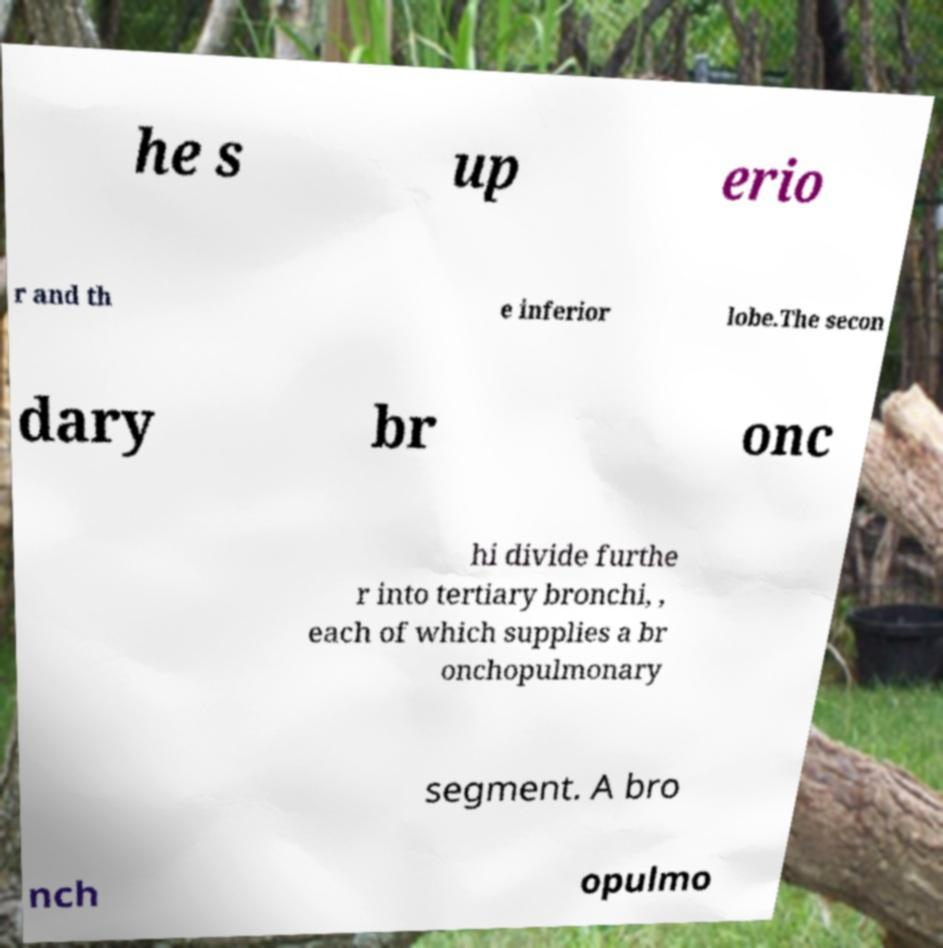Please identify and transcribe the text found in this image. he s up erio r and th e inferior lobe.The secon dary br onc hi divide furthe r into tertiary bronchi, , each of which supplies a br onchopulmonary segment. A bro nch opulmo 